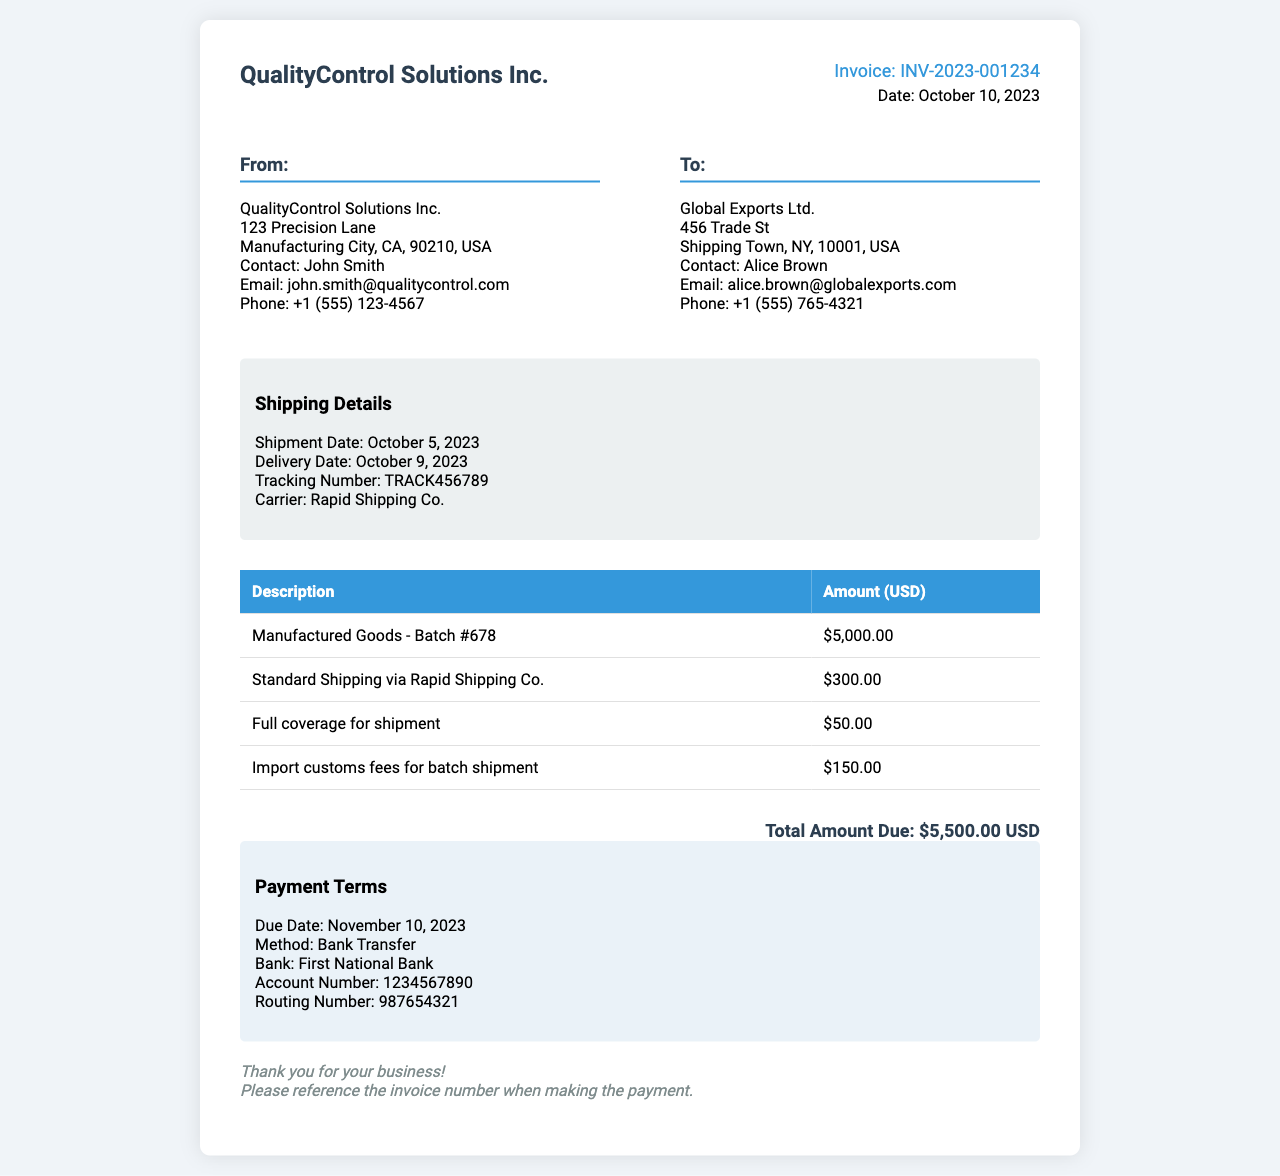what is the invoice number? The invoice number is clearly stated at the top of the document as "INV-2023-001234."
Answer: INV-2023-001234 what is the total amount due? The total amount due is mentioned in the total section and is "$5,500.00 USD."
Answer: $5,500.00 USD who is the contact person for the sender? The contact person for the sender is listed as John Smith in the "From" section.
Answer: John Smith what is the shipment date? The shipment date is provided in the shipping details, stating "October 5, 2023."
Answer: October 5, 2023 how much is charged for import customs fees? The charge for import customs fees is specified in the table as "$150.00."
Answer: $150.00 what company is responsible for the shipping? The shipping company mentioned in the shipping details is "Rapid Shipping Co."
Answer: Rapid Shipping Co when is the payment due date? The due date for payment is indicated under payment terms as "November 10, 2023."
Answer: November 10, 2023 how much is charged for full coverage of the shipment? The cost for full coverage of the shipment is listed in the table as "$50.00."
Answer: $50.00 what method is used for payment? The method for payment specified in the document is "Bank Transfer."
Answer: Bank Transfer 